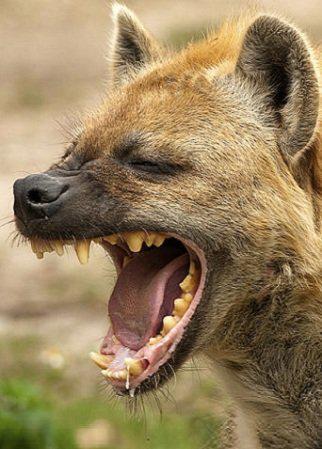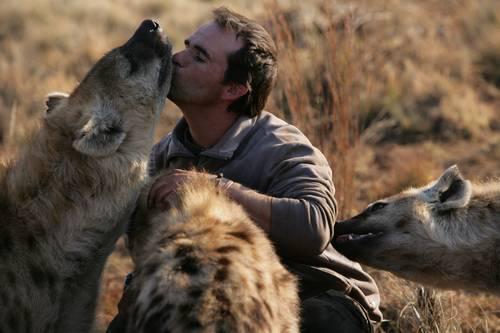The first image is the image on the left, the second image is the image on the right. Evaluate the accuracy of this statement regarding the images: "In one of the images there is a man surrounded by multiple hyenas.". Is it true? Answer yes or no. Yes. The first image is the image on the left, the second image is the image on the right. For the images shown, is this caption "An image shows a man posed with three hyenas." true? Answer yes or no. Yes. 